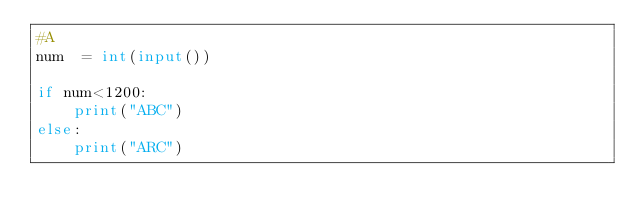<code> <loc_0><loc_0><loc_500><loc_500><_Python_>#A
num  = int(input())

if num<1200:
    print("ABC")
else:
    print("ARC")</code> 